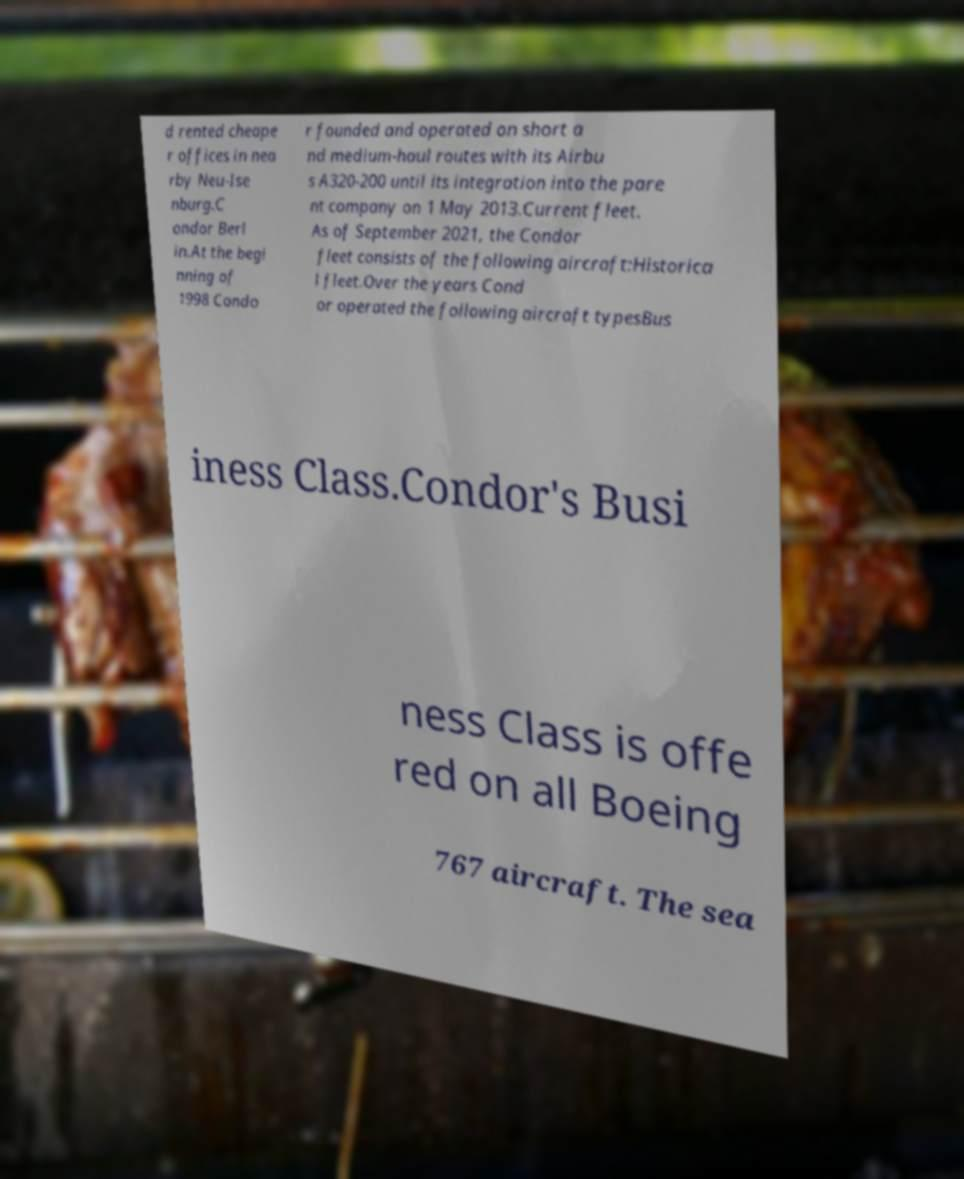Please identify and transcribe the text found in this image. d rented cheape r offices in nea rby Neu-Ise nburg.C ondor Berl in.At the begi nning of 1998 Condo r founded and operated on short a nd medium-haul routes with its Airbu s A320-200 until its integration into the pare nt company on 1 May 2013.Current fleet. As of September 2021, the Condor fleet consists of the following aircraft:Historica l fleet.Over the years Cond or operated the following aircraft typesBus iness Class.Condor's Busi ness Class is offe red on all Boeing 767 aircraft. The sea 